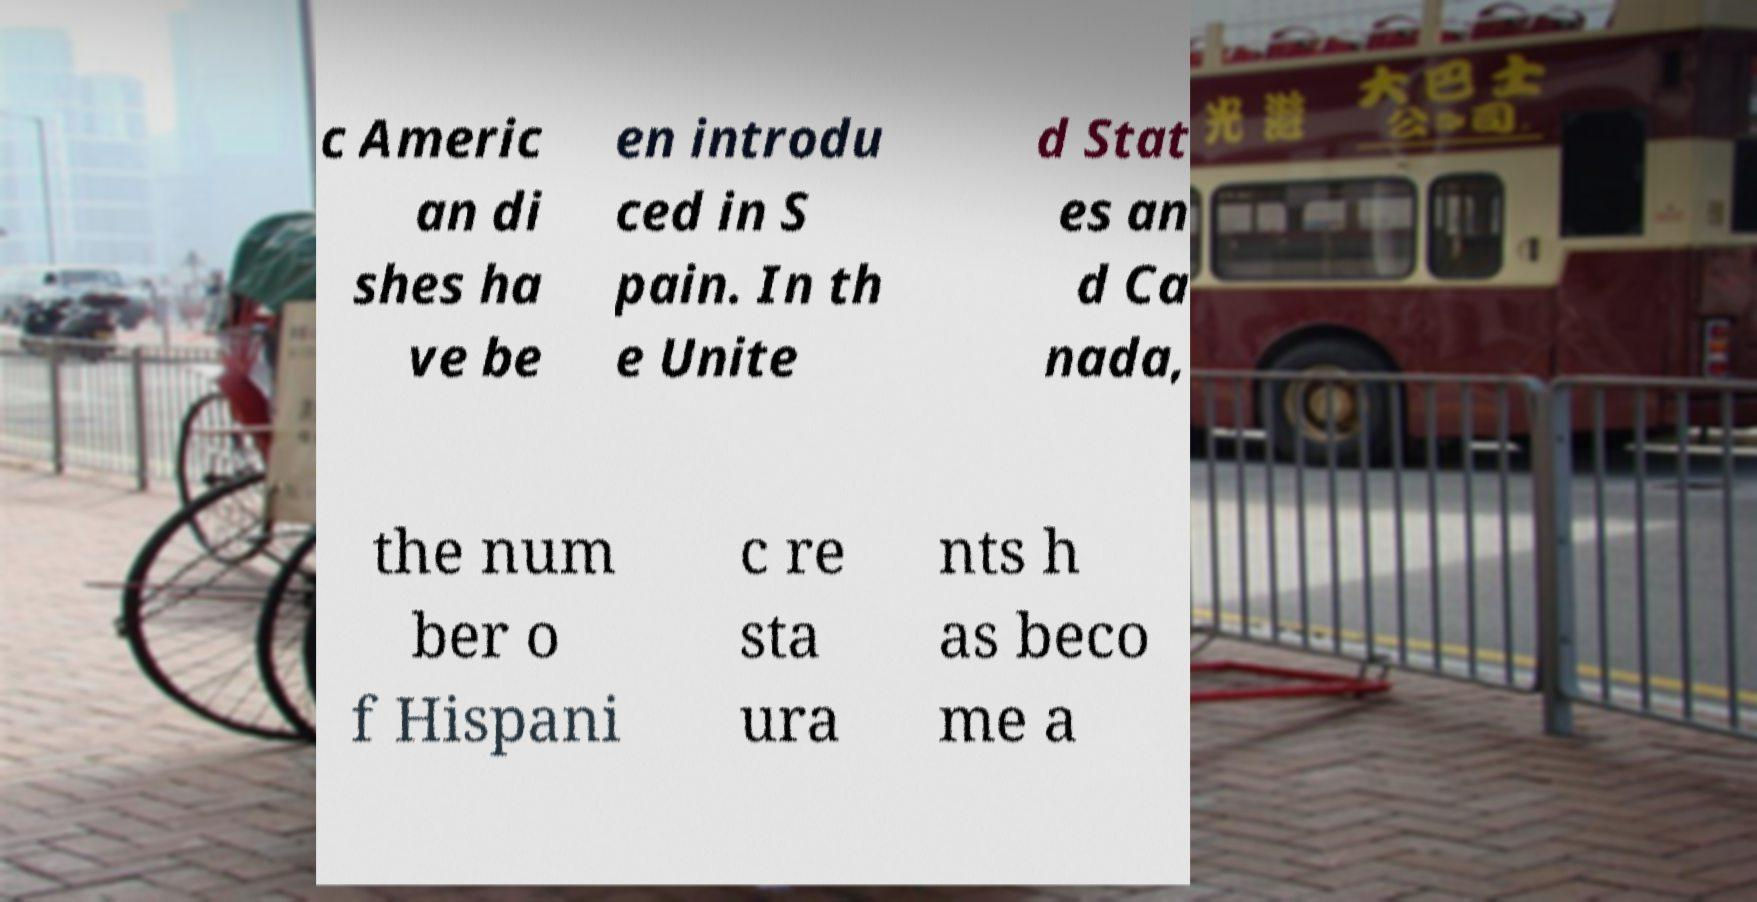Could you assist in decoding the text presented in this image and type it out clearly? c Americ an di shes ha ve be en introdu ced in S pain. In th e Unite d Stat es an d Ca nada, the num ber o f Hispani c re sta ura nts h as beco me a 